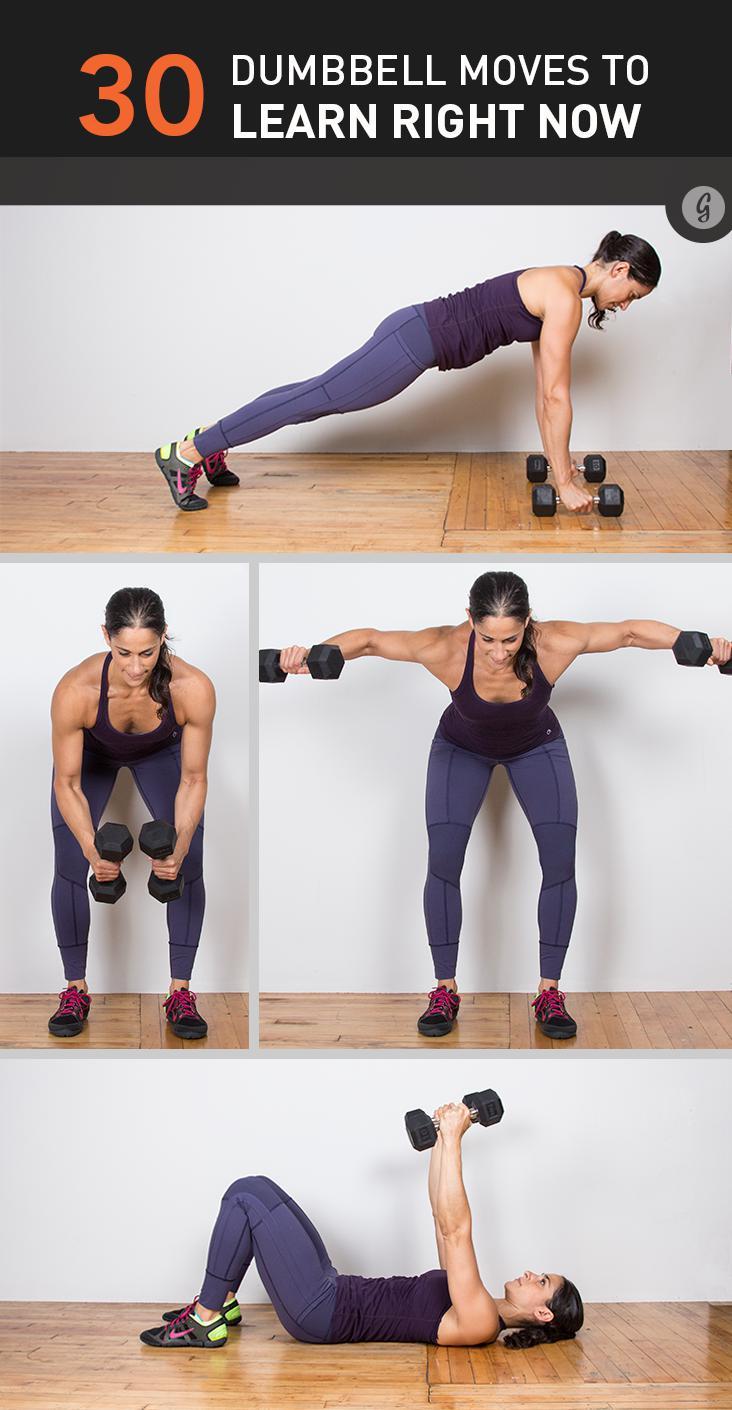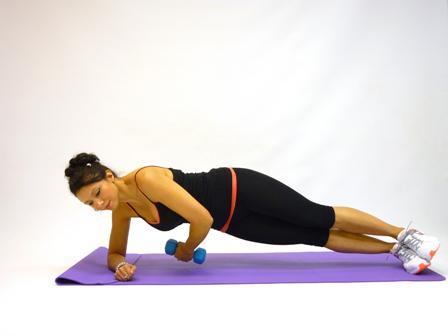The first image is the image on the left, the second image is the image on the right. Evaluate the accuracy of this statement regarding the images: "There are shirtless men lifting weights". Is it true? Answer yes or no. No. The first image is the image on the left, the second image is the image on the right. Analyze the images presented: Is the assertion "There are exactly three people working out in both images." valid? Answer yes or no. No. 